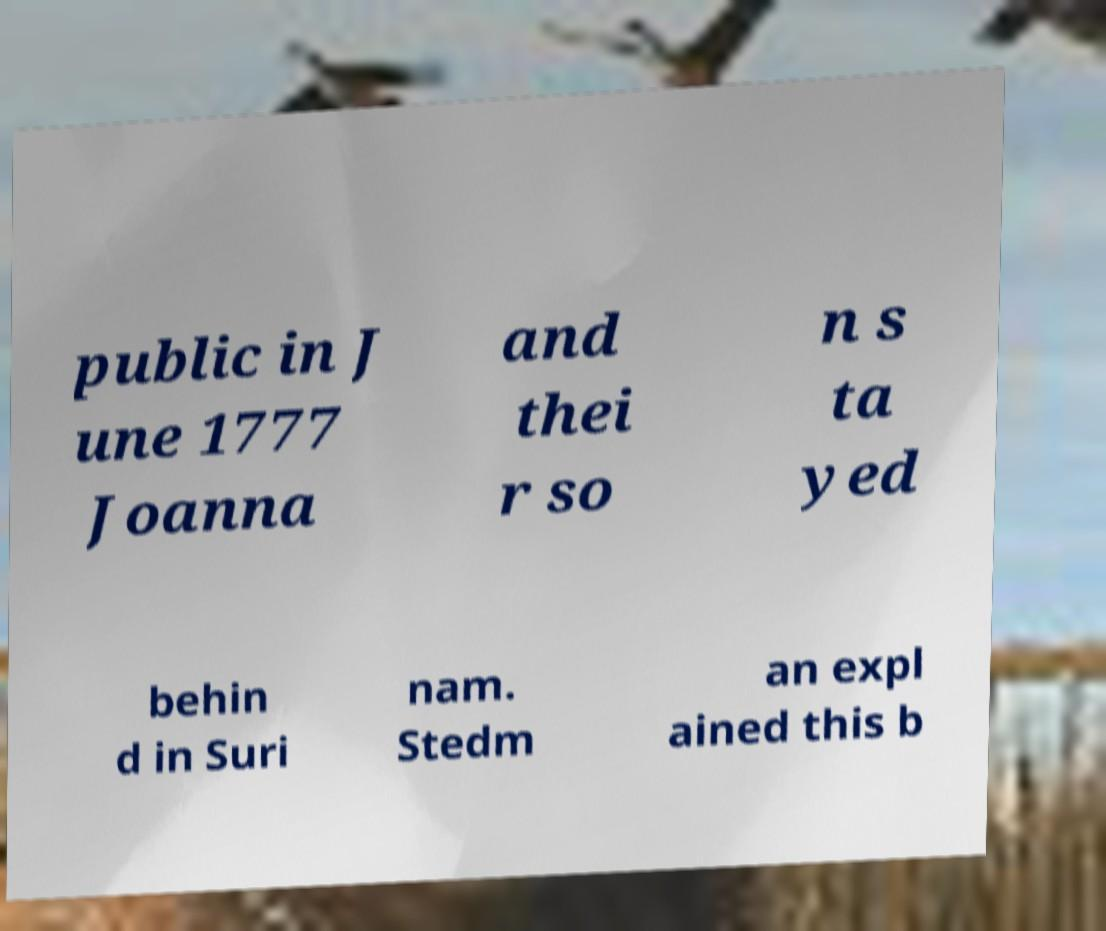What messages or text are displayed in this image? I need them in a readable, typed format. public in J une 1777 Joanna and thei r so n s ta yed behin d in Suri nam. Stedm an expl ained this b 